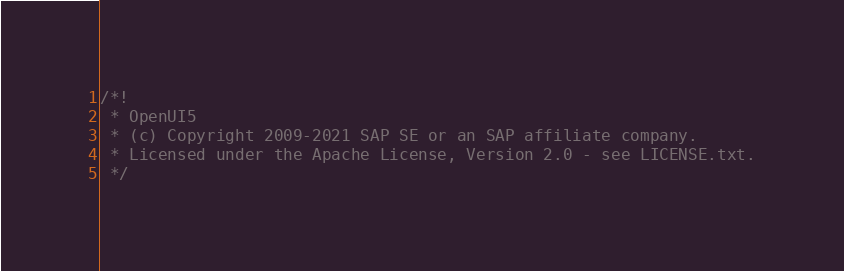<code> <loc_0><loc_0><loc_500><loc_500><_JavaScript_>/*!
 * OpenUI5
 * (c) Copyright 2009-2021 SAP SE or an SAP affiliate company.
 * Licensed under the Apache License, Version 2.0 - see LICENSE.txt.
 */</code> 